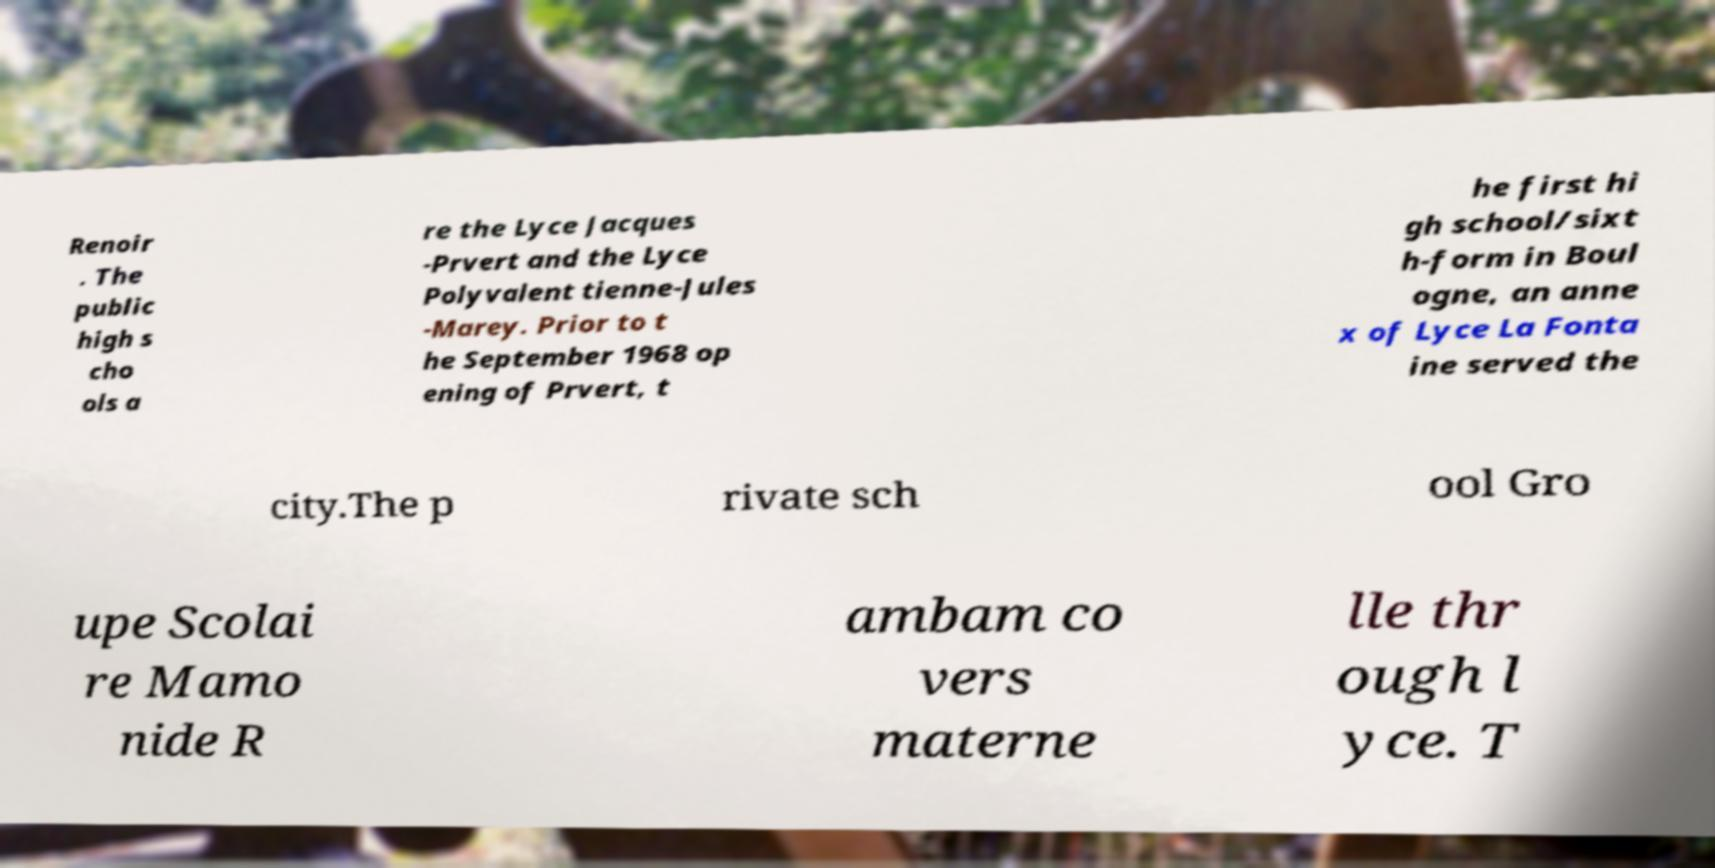Please identify and transcribe the text found in this image. Renoir . The public high s cho ols a re the Lyce Jacques -Prvert and the Lyce Polyvalent tienne-Jules -Marey. Prior to t he September 1968 op ening of Prvert, t he first hi gh school/sixt h-form in Boul ogne, an anne x of Lyce La Fonta ine served the city.The p rivate sch ool Gro upe Scolai re Mamo nide R ambam co vers materne lle thr ough l yce. T 